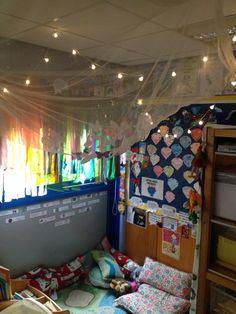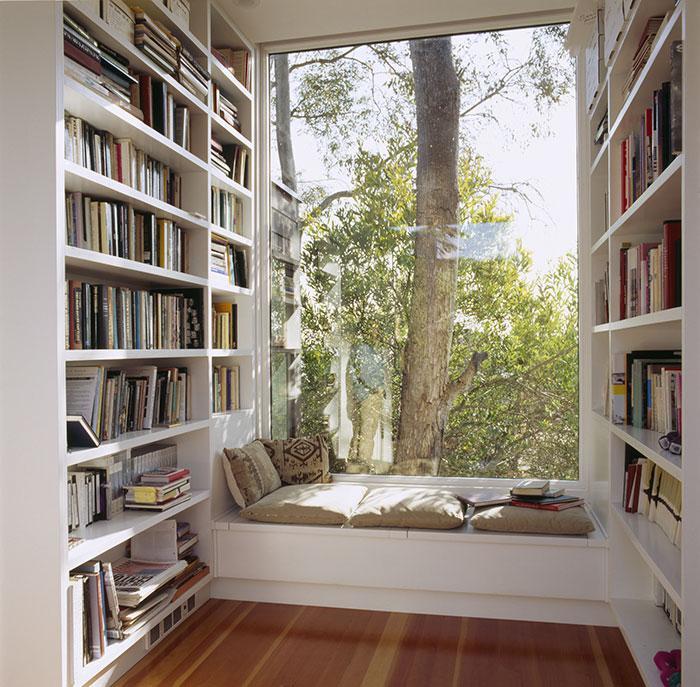The first image is the image on the left, the second image is the image on the right. Considering the images on both sides, is "Netting is draped above a reading area in the image on the left." valid? Answer yes or no. Yes. The first image is the image on the left, the second image is the image on the right. Examine the images to the left and right. Is the description "The left image features books arranged on tiered shelves of a wooden pyramid-shaped structure in a library with a wood floor." accurate? Answer yes or no. No. 